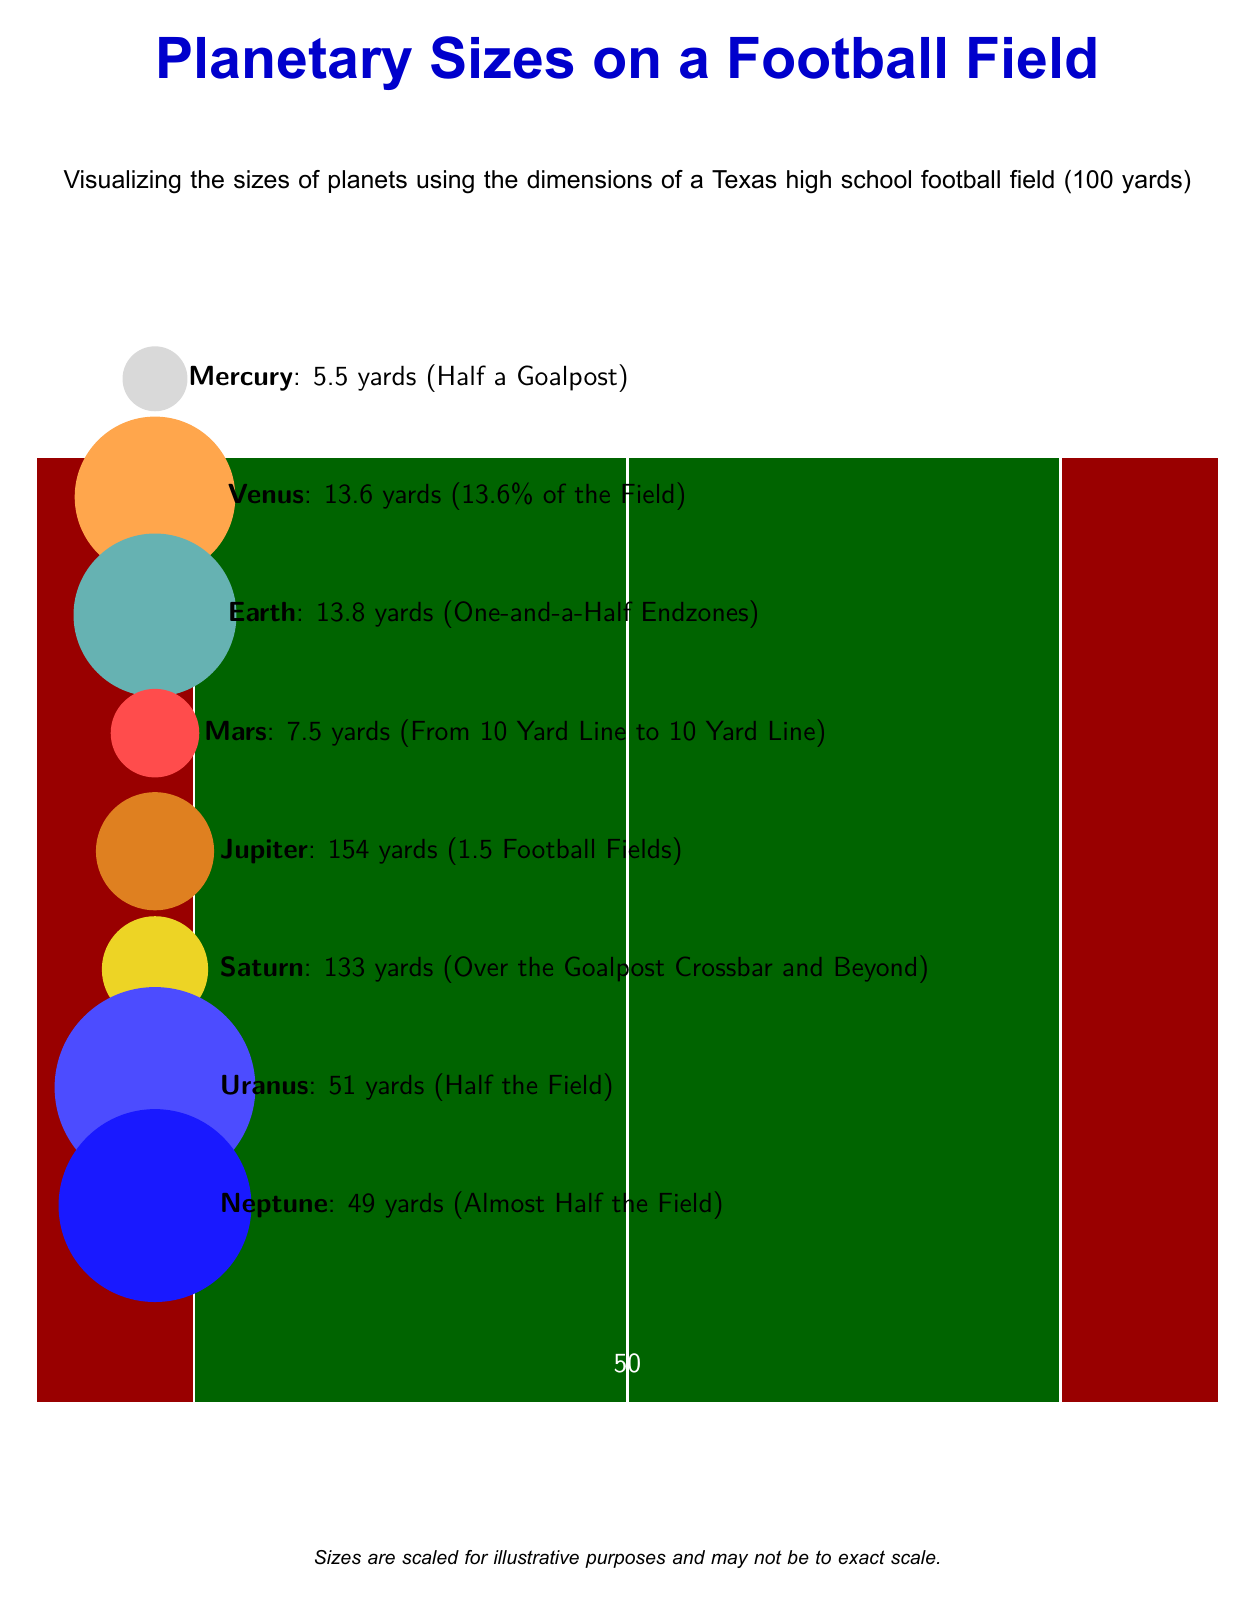What's the size of Jupiter in yards? Jupiter is represented as a circle on the diagram with a description that indicates its size is 154 yards.
Answer: 154 yards How many endzones does Earth’s size represent? Earth’s size is noted in the diagram as being "One-and-a-Half Endzones," indicating it is equivalent to 1.5 times the width of an end zone.
Answer: One-and-a-Half Endzones Which planet is the smallest? The diagram shows Mercury as the smallest planet with a size of 5.5 yards, clearly labelled above it.
Answer: Mercury What is the size of Neptune in yards? The diagram shows Neptune with a label indicating its size as 49 yards. This is how the viewer determines its size.
Answer: 49 yards Which planet is larger, Saturn or Uranus? With Saturn indicated at 133 yards and Uranus at 51 yards, we compare these values to determine that Saturn is larger, based on the respective sizes listed in the diagram.
Answer: Saturn How does Venus compare to Mars in size? The diagram lists Venus at 13.6 yards and Mars at 7.5 yards. Comparing the two sizes shows that Venus is larger than Mars, reflecting the numeric values next to each planet.
Answer: Venus is larger How much of the football field does Jupiter represent in comparison to its total length? The description in the diagram indicates that Jupiter is 154 yards, which translates to 1.5 football fields. This requires comparing Jupiter's size to the total length of a football field, leading to the conclusion.
Answer: 1.5 Football Fields What color represents Saturn on the diagram? The color of the circle representing Saturn in the diagram is labelled as yellow!70!brown, which is visibly apparent in the illustration.
Answer: Yellow!70!brown How many yards is the distance represented by Mercury on the diagram? The size of Mercury is specified in the diagram as 5.5 yards, which can be located in the description next to its representation.
Answer: 5.5 yards 